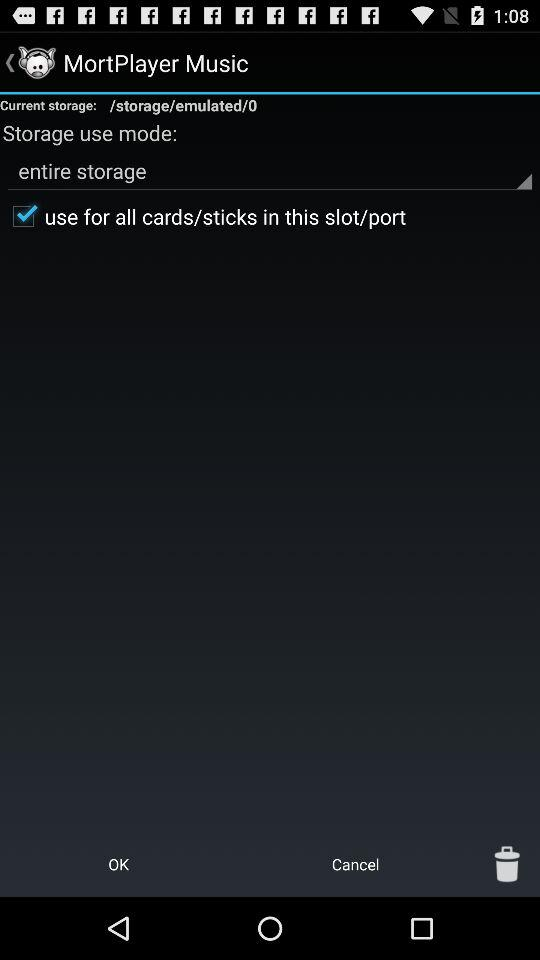Which "Storage use mode" has been selected? In "Storage use mode", "entire storage" has been selected. 